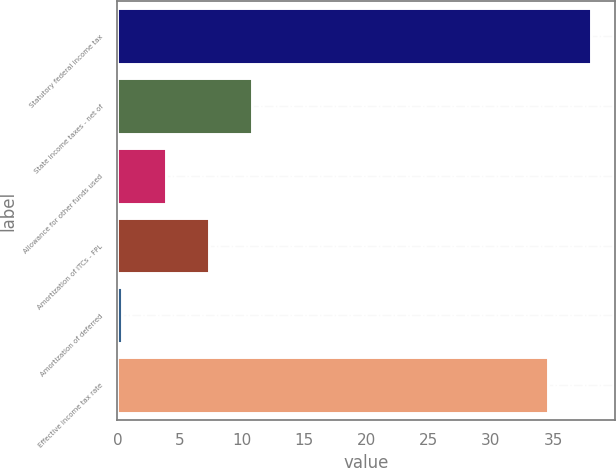Convert chart to OTSL. <chart><loc_0><loc_0><loc_500><loc_500><bar_chart><fcel>Statutory federal income tax<fcel>State income taxes - net of<fcel>Allowance for other funds used<fcel>Amortization of ITCs - FPL<fcel>Amortization of deferred<fcel>Effective income tax rate<nl><fcel>38.06<fcel>10.78<fcel>3.86<fcel>7.32<fcel>0.4<fcel>34.6<nl></chart> 